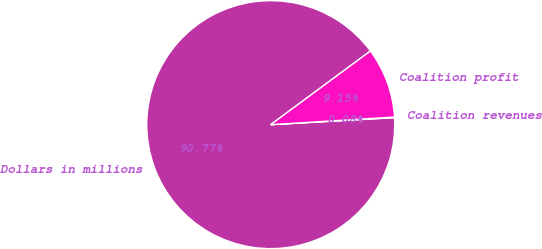Convert chart. <chart><loc_0><loc_0><loc_500><loc_500><pie_chart><fcel>Dollars in millions<fcel>Coalition revenues<fcel>Coalition profit<nl><fcel>90.77%<fcel>0.08%<fcel>9.15%<nl></chart> 